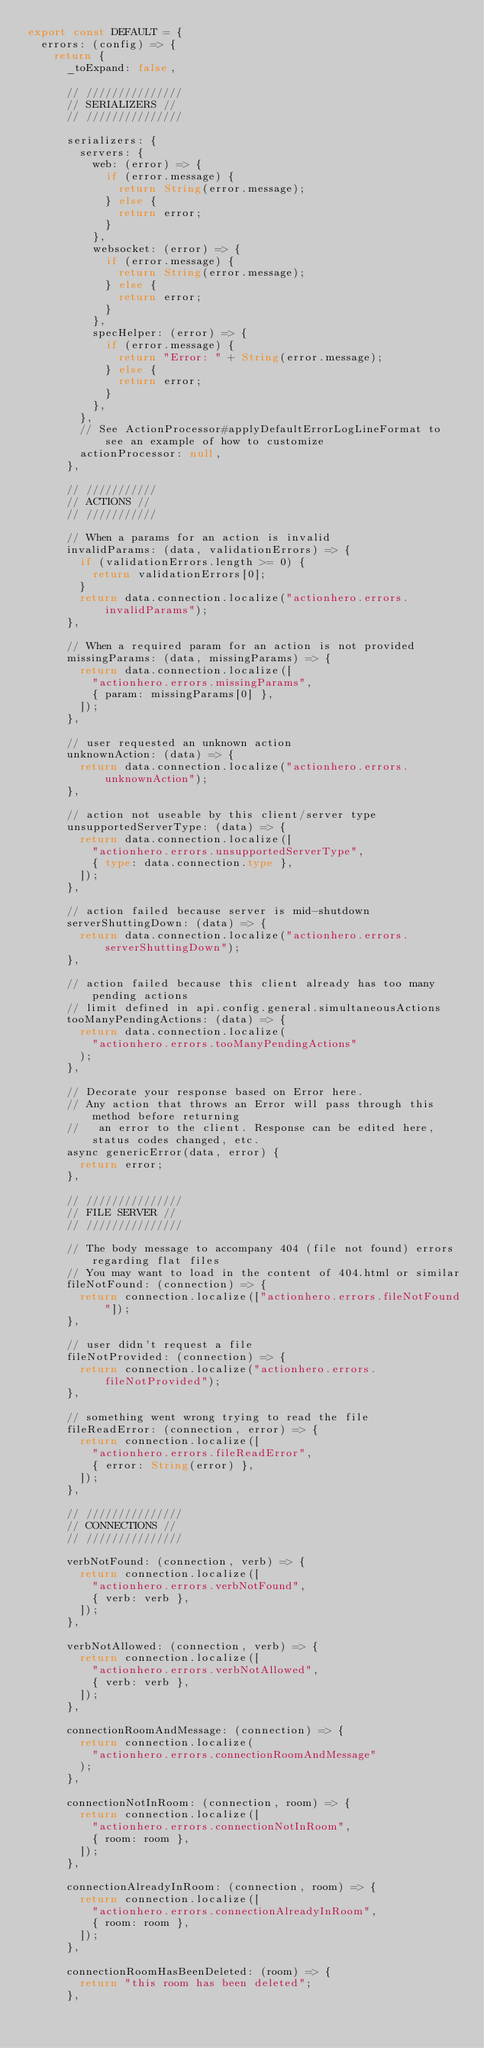<code> <loc_0><loc_0><loc_500><loc_500><_TypeScript_>export const DEFAULT = {
  errors: (config) => {
    return {
      _toExpand: false,

      // ///////////////
      // SERIALIZERS //
      // ///////////////

      serializers: {
        servers: {
          web: (error) => {
            if (error.message) {
              return String(error.message);
            } else {
              return error;
            }
          },
          websocket: (error) => {
            if (error.message) {
              return String(error.message);
            } else {
              return error;
            }
          },
          specHelper: (error) => {
            if (error.message) {
              return "Error: " + String(error.message);
            } else {
              return error;
            }
          },
        },
        // See ActionProcessor#applyDefaultErrorLogLineFormat to see an example of how to customize
        actionProcessor: null,
      },

      // ///////////
      // ACTIONS //
      // ///////////

      // When a params for an action is invalid
      invalidParams: (data, validationErrors) => {
        if (validationErrors.length >= 0) {
          return validationErrors[0];
        }
        return data.connection.localize("actionhero.errors.invalidParams");
      },

      // When a required param for an action is not provided
      missingParams: (data, missingParams) => {
        return data.connection.localize([
          "actionhero.errors.missingParams",
          { param: missingParams[0] },
        ]);
      },

      // user requested an unknown action
      unknownAction: (data) => {
        return data.connection.localize("actionhero.errors.unknownAction");
      },

      // action not useable by this client/server type
      unsupportedServerType: (data) => {
        return data.connection.localize([
          "actionhero.errors.unsupportedServerType",
          { type: data.connection.type },
        ]);
      },

      // action failed because server is mid-shutdown
      serverShuttingDown: (data) => {
        return data.connection.localize("actionhero.errors.serverShuttingDown");
      },

      // action failed because this client already has too many pending actions
      // limit defined in api.config.general.simultaneousActions
      tooManyPendingActions: (data) => {
        return data.connection.localize(
          "actionhero.errors.tooManyPendingActions"
        );
      },

      // Decorate your response based on Error here.
      // Any action that throws an Error will pass through this method before returning
      //   an error to the client. Response can be edited here, status codes changed, etc.
      async genericError(data, error) {
        return error;
      },

      // ///////////////
      // FILE SERVER //
      // ///////////////

      // The body message to accompany 404 (file not found) errors regarding flat files
      // You may want to load in the content of 404.html or similar
      fileNotFound: (connection) => {
        return connection.localize(["actionhero.errors.fileNotFound"]);
      },

      // user didn't request a file
      fileNotProvided: (connection) => {
        return connection.localize("actionhero.errors.fileNotProvided");
      },

      // something went wrong trying to read the file
      fileReadError: (connection, error) => {
        return connection.localize([
          "actionhero.errors.fileReadError",
          { error: String(error) },
        ]);
      },

      // ///////////////
      // CONNECTIONS //
      // ///////////////

      verbNotFound: (connection, verb) => {
        return connection.localize([
          "actionhero.errors.verbNotFound",
          { verb: verb },
        ]);
      },

      verbNotAllowed: (connection, verb) => {
        return connection.localize([
          "actionhero.errors.verbNotAllowed",
          { verb: verb },
        ]);
      },

      connectionRoomAndMessage: (connection) => {
        return connection.localize(
          "actionhero.errors.connectionRoomAndMessage"
        );
      },

      connectionNotInRoom: (connection, room) => {
        return connection.localize([
          "actionhero.errors.connectionNotInRoom",
          { room: room },
        ]);
      },

      connectionAlreadyInRoom: (connection, room) => {
        return connection.localize([
          "actionhero.errors.connectionAlreadyInRoom",
          { room: room },
        ]);
      },

      connectionRoomHasBeenDeleted: (room) => {
        return "this room has been deleted";
      },
</code> 